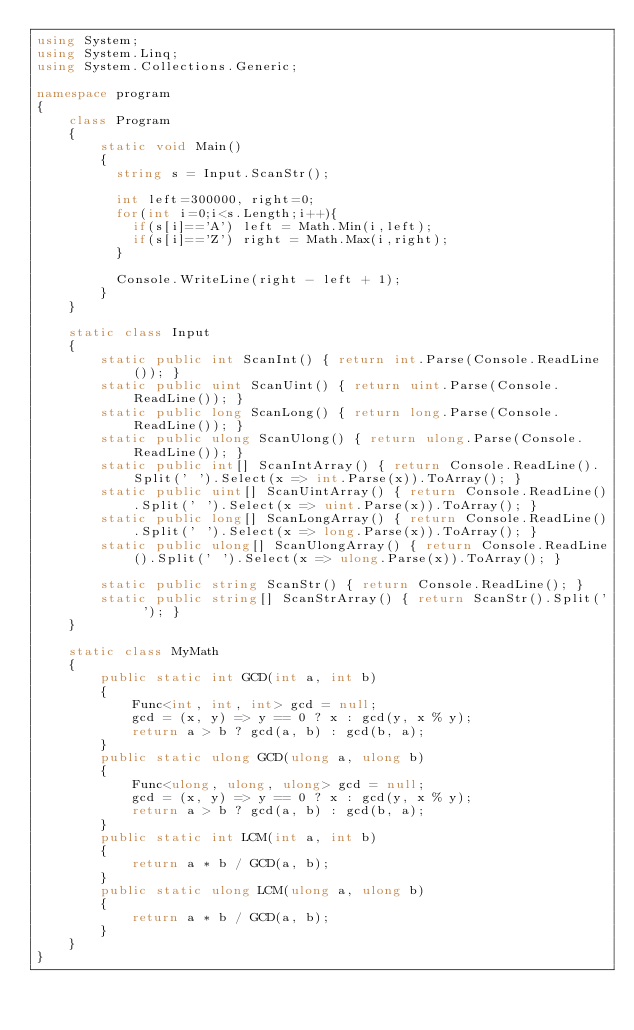Convert code to text. <code><loc_0><loc_0><loc_500><loc_500><_C#_>using System;
using System.Linq;
using System.Collections.Generic;

namespace program
{
    class Program
    {
        static void Main()
        {
          string s = Input.ScanStr();
          
          int left=300000, right=0;
          for(int i=0;i<s.Length;i++){
            if(s[i]=='A') left = Math.Min(i,left);
            if(s[i]=='Z') right = Math.Max(i,right);
          }
            
          Console.WriteLine(right - left + 1);
        }
    }

    static class Input
    {
        static public int ScanInt() { return int.Parse(Console.ReadLine()); }
        static public uint ScanUint() { return uint.Parse(Console.ReadLine()); }
        static public long ScanLong() { return long.Parse(Console.ReadLine()); }
        static public ulong ScanUlong() { return ulong.Parse(Console.ReadLine()); }
        static public int[] ScanIntArray() { return Console.ReadLine().Split(' ').Select(x => int.Parse(x)).ToArray(); }
        static public uint[] ScanUintArray() { return Console.ReadLine().Split(' ').Select(x => uint.Parse(x)).ToArray(); }
        static public long[] ScanLongArray() { return Console.ReadLine().Split(' ').Select(x => long.Parse(x)).ToArray(); }
        static public ulong[] ScanUlongArray() { return Console.ReadLine().Split(' ').Select(x => ulong.Parse(x)).ToArray(); }

        static public string ScanStr() { return Console.ReadLine(); }
        static public string[] ScanStrArray() { return ScanStr().Split(' '); }
    }

    static class MyMath
    {
        public static int GCD(int a, int b)
        {
            Func<int, int, int> gcd = null;
            gcd = (x, y) => y == 0 ? x : gcd(y, x % y);
            return a > b ? gcd(a, b) : gcd(b, a);
        }
        public static ulong GCD(ulong a, ulong b)
        {
            Func<ulong, ulong, ulong> gcd = null;
            gcd = (x, y) => y == 0 ? x : gcd(y, x % y);
            return a > b ? gcd(a, b) : gcd(b, a);
        }
        public static int LCM(int a, int b)
        {
            return a * b / GCD(a, b);
        }
        public static ulong LCM(ulong a, ulong b)
        {
            return a * b / GCD(a, b);
        }
    }
}
</code> 